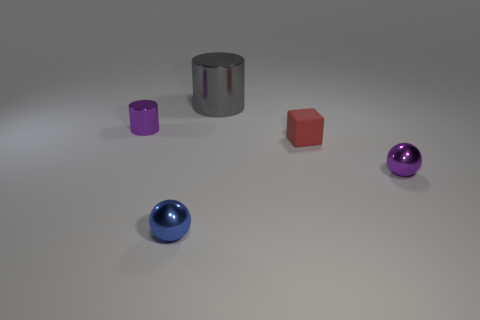Add 5 tiny matte blocks. How many objects exist? 10 Subtract all blue balls. How many balls are left? 1 Subtract all cylinders. How many objects are left? 3 Subtract all gray blocks. Subtract all red cylinders. How many blocks are left? 1 Subtract all green cylinders. How many yellow spheres are left? 0 Subtract 0 yellow cylinders. How many objects are left? 5 Subtract 1 cylinders. How many cylinders are left? 1 Subtract all blue balls. Subtract all blue metal spheres. How many objects are left? 3 Add 2 red blocks. How many red blocks are left? 3 Add 4 small purple metal objects. How many small purple metal objects exist? 6 